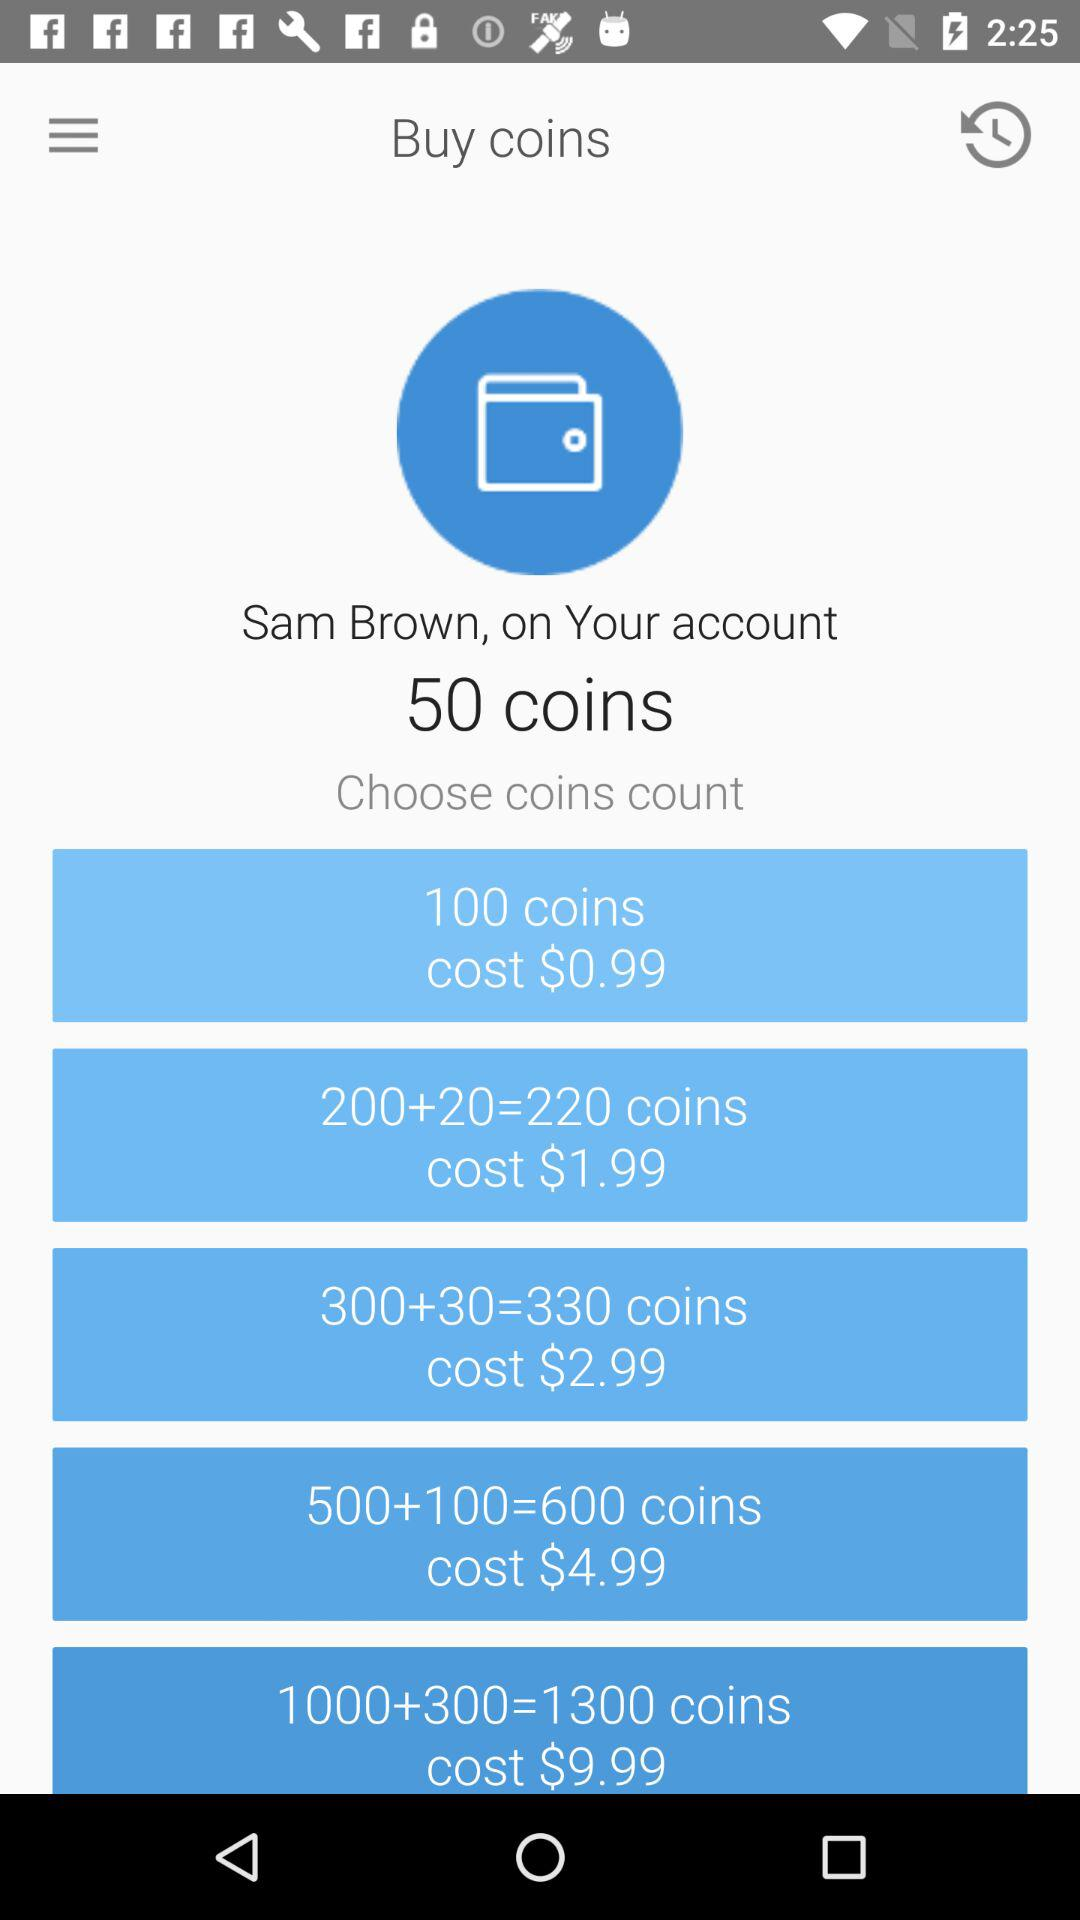What is the name of the account holder? The name of the account holder is Sam Brown. 